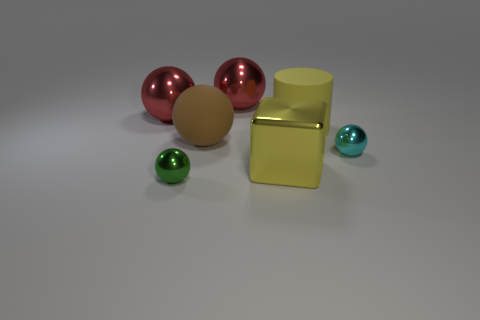Imagine this is a part of a larger art installation. What themes could it be exploring? Within the context of an art installation, this arrangement could be exploring themes such as the interplay between natural and artificial materials, the beauty found in simple geometric shapes, and the harmony of muted versus vibrant colors. If you were to add another object to this composition, what would it be and why? I'd consider adding a piece of glass or crystal. Its transparent nature would introduce an element of reflection and refraction, adding depth and complexity to the installation while complementing the existing objects. 